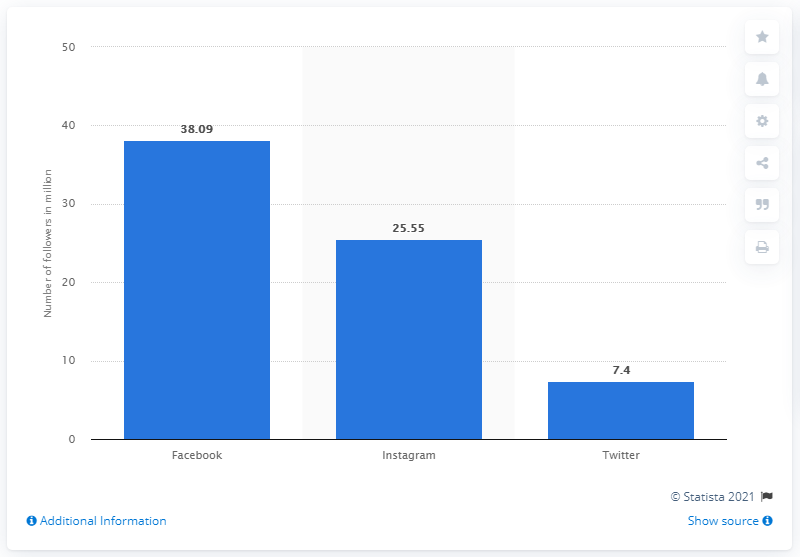Give some essential details in this illustration. As of November 2019, Paris Saint-Germain had 38,090 Facebook fans. 